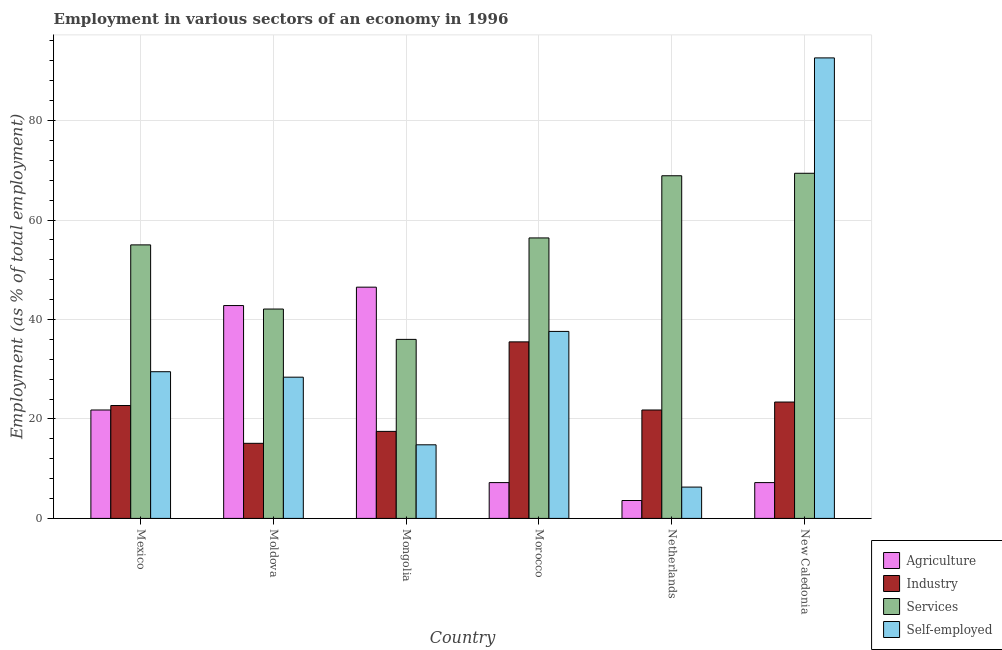How many groups of bars are there?
Ensure brevity in your answer.  6. What is the label of the 2nd group of bars from the left?
Give a very brief answer. Moldova. What is the percentage of self employed workers in Netherlands?
Offer a terse response. 6.3. Across all countries, what is the maximum percentage of self employed workers?
Ensure brevity in your answer.  92.6. Across all countries, what is the minimum percentage of workers in agriculture?
Give a very brief answer. 3.6. In which country was the percentage of workers in industry maximum?
Make the answer very short. Morocco. What is the total percentage of workers in services in the graph?
Keep it short and to the point. 327.8. What is the difference between the percentage of workers in industry in Mexico and that in Morocco?
Your answer should be compact. -12.8. What is the difference between the percentage of workers in agriculture in Mexico and the percentage of workers in industry in Moldova?
Keep it short and to the point. 6.7. What is the average percentage of workers in agriculture per country?
Ensure brevity in your answer.  21.52. What is the difference between the percentage of workers in agriculture and percentage of workers in industry in Moldova?
Make the answer very short. 27.7. In how many countries, is the percentage of self employed workers greater than 56 %?
Your answer should be compact. 1. What is the ratio of the percentage of self employed workers in Moldova to that in Mongolia?
Ensure brevity in your answer.  1.92. Is the percentage of workers in agriculture in Moldova less than that in Mongolia?
Your answer should be very brief. Yes. Is the difference between the percentage of workers in industry in Mexico and Moldova greater than the difference between the percentage of self employed workers in Mexico and Moldova?
Offer a terse response. Yes. What is the difference between the highest and the second highest percentage of workers in services?
Your answer should be compact. 0.5. What is the difference between the highest and the lowest percentage of self employed workers?
Offer a very short reply. 86.3. What does the 3rd bar from the left in Morocco represents?
Your answer should be very brief. Services. What does the 4th bar from the right in Moldova represents?
Keep it short and to the point. Agriculture. How many bars are there?
Offer a very short reply. 24. Are all the bars in the graph horizontal?
Offer a terse response. No. How many countries are there in the graph?
Offer a very short reply. 6. Are the values on the major ticks of Y-axis written in scientific E-notation?
Provide a short and direct response. No. Does the graph contain any zero values?
Provide a short and direct response. No. Where does the legend appear in the graph?
Keep it short and to the point. Bottom right. How are the legend labels stacked?
Your answer should be compact. Vertical. What is the title of the graph?
Your answer should be very brief. Employment in various sectors of an economy in 1996. What is the label or title of the X-axis?
Your answer should be very brief. Country. What is the label or title of the Y-axis?
Provide a short and direct response. Employment (as % of total employment). What is the Employment (as % of total employment) in Agriculture in Mexico?
Offer a very short reply. 21.8. What is the Employment (as % of total employment) of Industry in Mexico?
Keep it short and to the point. 22.7. What is the Employment (as % of total employment) of Services in Mexico?
Provide a succinct answer. 55. What is the Employment (as % of total employment) in Self-employed in Mexico?
Your answer should be very brief. 29.5. What is the Employment (as % of total employment) in Agriculture in Moldova?
Your answer should be compact. 42.8. What is the Employment (as % of total employment) in Industry in Moldova?
Your answer should be compact. 15.1. What is the Employment (as % of total employment) in Services in Moldova?
Provide a short and direct response. 42.1. What is the Employment (as % of total employment) of Self-employed in Moldova?
Offer a very short reply. 28.4. What is the Employment (as % of total employment) of Agriculture in Mongolia?
Provide a short and direct response. 46.5. What is the Employment (as % of total employment) in Self-employed in Mongolia?
Ensure brevity in your answer.  14.8. What is the Employment (as % of total employment) of Agriculture in Morocco?
Provide a succinct answer. 7.2. What is the Employment (as % of total employment) in Industry in Morocco?
Your answer should be very brief. 35.5. What is the Employment (as % of total employment) in Services in Morocco?
Offer a very short reply. 56.4. What is the Employment (as % of total employment) in Self-employed in Morocco?
Give a very brief answer. 37.6. What is the Employment (as % of total employment) of Agriculture in Netherlands?
Provide a succinct answer. 3.6. What is the Employment (as % of total employment) in Industry in Netherlands?
Give a very brief answer. 21.8. What is the Employment (as % of total employment) in Services in Netherlands?
Keep it short and to the point. 68.9. What is the Employment (as % of total employment) in Self-employed in Netherlands?
Your response must be concise. 6.3. What is the Employment (as % of total employment) of Agriculture in New Caledonia?
Make the answer very short. 7.2. What is the Employment (as % of total employment) of Industry in New Caledonia?
Give a very brief answer. 23.4. What is the Employment (as % of total employment) in Services in New Caledonia?
Ensure brevity in your answer.  69.4. What is the Employment (as % of total employment) of Self-employed in New Caledonia?
Ensure brevity in your answer.  92.6. Across all countries, what is the maximum Employment (as % of total employment) in Agriculture?
Your response must be concise. 46.5. Across all countries, what is the maximum Employment (as % of total employment) of Industry?
Give a very brief answer. 35.5. Across all countries, what is the maximum Employment (as % of total employment) of Services?
Provide a short and direct response. 69.4. Across all countries, what is the maximum Employment (as % of total employment) in Self-employed?
Offer a terse response. 92.6. Across all countries, what is the minimum Employment (as % of total employment) in Agriculture?
Give a very brief answer. 3.6. Across all countries, what is the minimum Employment (as % of total employment) of Industry?
Your answer should be compact. 15.1. Across all countries, what is the minimum Employment (as % of total employment) in Self-employed?
Provide a succinct answer. 6.3. What is the total Employment (as % of total employment) in Agriculture in the graph?
Provide a short and direct response. 129.1. What is the total Employment (as % of total employment) in Industry in the graph?
Your answer should be very brief. 136. What is the total Employment (as % of total employment) of Services in the graph?
Make the answer very short. 327.8. What is the total Employment (as % of total employment) of Self-employed in the graph?
Ensure brevity in your answer.  209.2. What is the difference between the Employment (as % of total employment) in Agriculture in Mexico and that in Moldova?
Provide a short and direct response. -21. What is the difference between the Employment (as % of total employment) of Industry in Mexico and that in Moldova?
Keep it short and to the point. 7.6. What is the difference between the Employment (as % of total employment) of Agriculture in Mexico and that in Mongolia?
Provide a short and direct response. -24.7. What is the difference between the Employment (as % of total employment) of Self-employed in Mexico and that in Mongolia?
Offer a very short reply. 14.7. What is the difference between the Employment (as % of total employment) in Industry in Mexico and that in Morocco?
Provide a short and direct response. -12.8. What is the difference between the Employment (as % of total employment) of Services in Mexico and that in Morocco?
Your response must be concise. -1.4. What is the difference between the Employment (as % of total employment) of Agriculture in Mexico and that in Netherlands?
Offer a terse response. 18.2. What is the difference between the Employment (as % of total employment) in Self-employed in Mexico and that in Netherlands?
Keep it short and to the point. 23.2. What is the difference between the Employment (as % of total employment) in Industry in Mexico and that in New Caledonia?
Provide a succinct answer. -0.7. What is the difference between the Employment (as % of total employment) of Services in Mexico and that in New Caledonia?
Offer a terse response. -14.4. What is the difference between the Employment (as % of total employment) in Self-employed in Mexico and that in New Caledonia?
Provide a succinct answer. -63.1. What is the difference between the Employment (as % of total employment) in Agriculture in Moldova and that in Mongolia?
Give a very brief answer. -3.7. What is the difference between the Employment (as % of total employment) of Services in Moldova and that in Mongolia?
Offer a terse response. 6.1. What is the difference between the Employment (as % of total employment) of Agriculture in Moldova and that in Morocco?
Keep it short and to the point. 35.6. What is the difference between the Employment (as % of total employment) in Industry in Moldova and that in Morocco?
Provide a succinct answer. -20.4. What is the difference between the Employment (as % of total employment) of Services in Moldova and that in Morocco?
Offer a terse response. -14.3. What is the difference between the Employment (as % of total employment) of Agriculture in Moldova and that in Netherlands?
Provide a succinct answer. 39.2. What is the difference between the Employment (as % of total employment) in Services in Moldova and that in Netherlands?
Give a very brief answer. -26.8. What is the difference between the Employment (as % of total employment) in Self-employed in Moldova and that in Netherlands?
Keep it short and to the point. 22.1. What is the difference between the Employment (as % of total employment) in Agriculture in Moldova and that in New Caledonia?
Make the answer very short. 35.6. What is the difference between the Employment (as % of total employment) in Industry in Moldova and that in New Caledonia?
Provide a succinct answer. -8.3. What is the difference between the Employment (as % of total employment) in Services in Moldova and that in New Caledonia?
Offer a terse response. -27.3. What is the difference between the Employment (as % of total employment) of Self-employed in Moldova and that in New Caledonia?
Keep it short and to the point. -64.2. What is the difference between the Employment (as % of total employment) in Agriculture in Mongolia and that in Morocco?
Make the answer very short. 39.3. What is the difference between the Employment (as % of total employment) of Industry in Mongolia and that in Morocco?
Provide a short and direct response. -18. What is the difference between the Employment (as % of total employment) of Services in Mongolia and that in Morocco?
Provide a succinct answer. -20.4. What is the difference between the Employment (as % of total employment) of Self-employed in Mongolia and that in Morocco?
Provide a succinct answer. -22.8. What is the difference between the Employment (as % of total employment) in Agriculture in Mongolia and that in Netherlands?
Ensure brevity in your answer.  42.9. What is the difference between the Employment (as % of total employment) in Industry in Mongolia and that in Netherlands?
Ensure brevity in your answer.  -4.3. What is the difference between the Employment (as % of total employment) in Services in Mongolia and that in Netherlands?
Offer a terse response. -32.9. What is the difference between the Employment (as % of total employment) in Self-employed in Mongolia and that in Netherlands?
Your answer should be compact. 8.5. What is the difference between the Employment (as % of total employment) in Agriculture in Mongolia and that in New Caledonia?
Your answer should be compact. 39.3. What is the difference between the Employment (as % of total employment) in Industry in Mongolia and that in New Caledonia?
Your answer should be compact. -5.9. What is the difference between the Employment (as % of total employment) of Services in Mongolia and that in New Caledonia?
Keep it short and to the point. -33.4. What is the difference between the Employment (as % of total employment) in Self-employed in Mongolia and that in New Caledonia?
Ensure brevity in your answer.  -77.8. What is the difference between the Employment (as % of total employment) of Services in Morocco and that in Netherlands?
Ensure brevity in your answer.  -12.5. What is the difference between the Employment (as % of total employment) of Self-employed in Morocco and that in Netherlands?
Keep it short and to the point. 31.3. What is the difference between the Employment (as % of total employment) of Agriculture in Morocco and that in New Caledonia?
Your response must be concise. 0. What is the difference between the Employment (as % of total employment) in Services in Morocco and that in New Caledonia?
Your response must be concise. -13. What is the difference between the Employment (as % of total employment) of Self-employed in Morocco and that in New Caledonia?
Offer a very short reply. -55. What is the difference between the Employment (as % of total employment) in Services in Netherlands and that in New Caledonia?
Your answer should be compact. -0.5. What is the difference between the Employment (as % of total employment) in Self-employed in Netherlands and that in New Caledonia?
Your answer should be very brief. -86.3. What is the difference between the Employment (as % of total employment) in Agriculture in Mexico and the Employment (as % of total employment) in Industry in Moldova?
Offer a very short reply. 6.7. What is the difference between the Employment (as % of total employment) of Agriculture in Mexico and the Employment (as % of total employment) of Services in Moldova?
Ensure brevity in your answer.  -20.3. What is the difference between the Employment (as % of total employment) in Agriculture in Mexico and the Employment (as % of total employment) in Self-employed in Moldova?
Provide a short and direct response. -6.6. What is the difference between the Employment (as % of total employment) of Industry in Mexico and the Employment (as % of total employment) of Services in Moldova?
Give a very brief answer. -19.4. What is the difference between the Employment (as % of total employment) in Industry in Mexico and the Employment (as % of total employment) in Self-employed in Moldova?
Ensure brevity in your answer.  -5.7. What is the difference between the Employment (as % of total employment) of Services in Mexico and the Employment (as % of total employment) of Self-employed in Moldova?
Offer a terse response. 26.6. What is the difference between the Employment (as % of total employment) of Agriculture in Mexico and the Employment (as % of total employment) of Services in Mongolia?
Your answer should be compact. -14.2. What is the difference between the Employment (as % of total employment) in Services in Mexico and the Employment (as % of total employment) in Self-employed in Mongolia?
Provide a succinct answer. 40.2. What is the difference between the Employment (as % of total employment) in Agriculture in Mexico and the Employment (as % of total employment) in Industry in Morocco?
Your answer should be very brief. -13.7. What is the difference between the Employment (as % of total employment) in Agriculture in Mexico and the Employment (as % of total employment) in Services in Morocco?
Provide a succinct answer. -34.6. What is the difference between the Employment (as % of total employment) in Agriculture in Mexico and the Employment (as % of total employment) in Self-employed in Morocco?
Your answer should be very brief. -15.8. What is the difference between the Employment (as % of total employment) in Industry in Mexico and the Employment (as % of total employment) in Services in Morocco?
Give a very brief answer. -33.7. What is the difference between the Employment (as % of total employment) of Industry in Mexico and the Employment (as % of total employment) of Self-employed in Morocco?
Ensure brevity in your answer.  -14.9. What is the difference between the Employment (as % of total employment) of Agriculture in Mexico and the Employment (as % of total employment) of Industry in Netherlands?
Provide a short and direct response. 0. What is the difference between the Employment (as % of total employment) of Agriculture in Mexico and the Employment (as % of total employment) of Services in Netherlands?
Provide a short and direct response. -47.1. What is the difference between the Employment (as % of total employment) of Agriculture in Mexico and the Employment (as % of total employment) of Self-employed in Netherlands?
Your answer should be compact. 15.5. What is the difference between the Employment (as % of total employment) in Industry in Mexico and the Employment (as % of total employment) in Services in Netherlands?
Provide a short and direct response. -46.2. What is the difference between the Employment (as % of total employment) in Services in Mexico and the Employment (as % of total employment) in Self-employed in Netherlands?
Your answer should be very brief. 48.7. What is the difference between the Employment (as % of total employment) of Agriculture in Mexico and the Employment (as % of total employment) of Services in New Caledonia?
Make the answer very short. -47.6. What is the difference between the Employment (as % of total employment) in Agriculture in Mexico and the Employment (as % of total employment) in Self-employed in New Caledonia?
Your response must be concise. -70.8. What is the difference between the Employment (as % of total employment) of Industry in Mexico and the Employment (as % of total employment) of Services in New Caledonia?
Your response must be concise. -46.7. What is the difference between the Employment (as % of total employment) of Industry in Mexico and the Employment (as % of total employment) of Self-employed in New Caledonia?
Offer a terse response. -69.9. What is the difference between the Employment (as % of total employment) in Services in Mexico and the Employment (as % of total employment) in Self-employed in New Caledonia?
Ensure brevity in your answer.  -37.6. What is the difference between the Employment (as % of total employment) in Agriculture in Moldova and the Employment (as % of total employment) in Industry in Mongolia?
Offer a very short reply. 25.3. What is the difference between the Employment (as % of total employment) of Agriculture in Moldova and the Employment (as % of total employment) of Self-employed in Mongolia?
Make the answer very short. 28. What is the difference between the Employment (as % of total employment) of Industry in Moldova and the Employment (as % of total employment) of Services in Mongolia?
Provide a succinct answer. -20.9. What is the difference between the Employment (as % of total employment) of Industry in Moldova and the Employment (as % of total employment) of Self-employed in Mongolia?
Provide a short and direct response. 0.3. What is the difference between the Employment (as % of total employment) of Services in Moldova and the Employment (as % of total employment) of Self-employed in Mongolia?
Ensure brevity in your answer.  27.3. What is the difference between the Employment (as % of total employment) of Industry in Moldova and the Employment (as % of total employment) of Services in Morocco?
Ensure brevity in your answer.  -41.3. What is the difference between the Employment (as % of total employment) of Industry in Moldova and the Employment (as % of total employment) of Self-employed in Morocco?
Your answer should be compact. -22.5. What is the difference between the Employment (as % of total employment) of Services in Moldova and the Employment (as % of total employment) of Self-employed in Morocco?
Your answer should be very brief. 4.5. What is the difference between the Employment (as % of total employment) in Agriculture in Moldova and the Employment (as % of total employment) in Industry in Netherlands?
Provide a short and direct response. 21. What is the difference between the Employment (as % of total employment) of Agriculture in Moldova and the Employment (as % of total employment) of Services in Netherlands?
Offer a very short reply. -26.1. What is the difference between the Employment (as % of total employment) of Agriculture in Moldova and the Employment (as % of total employment) of Self-employed in Netherlands?
Your answer should be very brief. 36.5. What is the difference between the Employment (as % of total employment) of Industry in Moldova and the Employment (as % of total employment) of Services in Netherlands?
Ensure brevity in your answer.  -53.8. What is the difference between the Employment (as % of total employment) of Industry in Moldova and the Employment (as % of total employment) of Self-employed in Netherlands?
Your answer should be very brief. 8.8. What is the difference between the Employment (as % of total employment) of Services in Moldova and the Employment (as % of total employment) of Self-employed in Netherlands?
Offer a very short reply. 35.8. What is the difference between the Employment (as % of total employment) of Agriculture in Moldova and the Employment (as % of total employment) of Services in New Caledonia?
Keep it short and to the point. -26.6. What is the difference between the Employment (as % of total employment) in Agriculture in Moldova and the Employment (as % of total employment) in Self-employed in New Caledonia?
Provide a short and direct response. -49.8. What is the difference between the Employment (as % of total employment) of Industry in Moldova and the Employment (as % of total employment) of Services in New Caledonia?
Your answer should be compact. -54.3. What is the difference between the Employment (as % of total employment) of Industry in Moldova and the Employment (as % of total employment) of Self-employed in New Caledonia?
Ensure brevity in your answer.  -77.5. What is the difference between the Employment (as % of total employment) in Services in Moldova and the Employment (as % of total employment) in Self-employed in New Caledonia?
Offer a very short reply. -50.5. What is the difference between the Employment (as % of total employment) in Agriculture in Mongolia and the Employment (as % of total employment) in Industry in Morocco?
Keep it short and to the point. 11. What is the difference between the Employment (as % of total employment) of Agriculture in Mongolia and the Employment (as % of total employment) of Services in Morocco?
Provide a short and direct response. -9.9. What is the difference between the Employment (as % of total employment) of Industry in Mongolia and the Employment (as % of total employment) of Services in Morocco?
Give a very brief answer. -38.9. What is the difference between the Employment (as % of total employment) in Industry in Mongolia and the Employment (as % of total employment) in Self-employed in Morocco?
Your response must be concise. -20.1. What is the difference between the Employment (as % of total employment) in Services in Mongolia and the Employment (as % of total employment) in Self-employed in Morocco?
Your response must be concise. -1.6. What is the difference between the Employment (as % of total employment) of Agriculture in Mongolia and the Employment (as % of total employment) of Industry in Netherlands?
Your response must be concise. 24.7. What is the difference between the Employment (as % of total employment) in Agriculture in Mongolia and the Employment (as % of total employment) in Services in Netherlands?
Offer a terse response. -22.4. What is the difference between the Employment (as % of total employment) of Agriculture in Mongolia and the Employment (as % of total employment) of Self-employed in Netherlands?
Your answer should be very brief. 40.2. What is the difference between the Employment (as % of total employment) of Industry in Mongolia and the Employment (as % of total employment) of Services in Netherlands?
Provide a short and direct response. -51.4. What is the difference between the Employment (as % of total employment) of Services in Mongolia and the Employment (as % of total employment) of Self-employed in Netherlands?
Provide a short and direct response. 29.7. What is the difference between the Employment (as % of total employment) of Agriculture in Mongolia and the Employment (as % of total employment) of Industry in New Caledonia?
Offer a very short reply. 23.1. What is the difference between the Employment (as % of total employment) in Agriculture in Mongolia and the Employment (as % of total employment) in Services in New Caledonia?
Offer a very short reply. -22.9. What is the difference between the Employment (as % of total employment) of Agriculture in Mongolia and the Employment (as % of total employment) of Self-employed in New Caledonia?
Your answer should be very brief. -46.1. What is the difference between the Employment (as % of total employment) in Industry in Mongolia and the Employment (as % of total employment) in Services in New Caledonia?
Offer a terse response. -51.9. What is the difference between the Employment (as % of total employment) of Industry in Mongolia and the Employment (as % of total employment) of Self-employed in New Caledonia?
Offer a very short reply. -75.1. What is the difference between the Employment (as % of total employment) of Services in Mongolia and the Employment (as % of total employment) of Self-employed in New Caledonia?
Your response must be concise. -56.6. What is the difference between the Employment (as % of total employment) in Agriculture in Morocco and the Employment (as % of total employment) in Industry in Netherlands?
Provide a succinct answer. -14.6. What is the difference between the Employment (as % of total employment) in Agriculture in Morocco and the Employment (as % of total employment) in Services in Netherlands?
Provide a succinct answer. -61.7. What is the difference between the Employment (as % of total employment) of Industry in Morocco and the Employment (as % of total employment) of Services in Netherlands?
Keep it short and to the point. -33.4. What is the difference between the Employment (as % of total employment) in Industry in Morocco and the Employment (as % of total employment) in Self-employed in Netherlands?
Keep it short and to the point. 29.2. What is the difference between the Employment (as % of total employment) of Services in Morocco and the Employment (as % of total employment) of Self-employed in Netherlands?
Ensure brevity in your answer.  50.1. What is the difference between the Employment (as % of total employment) of Agriculture in Morocco and the Employment (as % of total employment) of Industry in New Caledonia?
Give a very brief answer. -16.2. What is the difference between the Employment (as % of total employment) in Agriculture in Morocco and the Employment (as % of total employment) in Services in New Caledonia?
Your response must be concise. -62.2. What is the difference between the Employment (as % of total employment) of Agriculture in Morocco and the Employment (as % of total employment) of Self-employed in New Caledonia?
Give a very brief answer. -85.4. What is the difference between the Employment (as % of total employment) of Industry in Morocco and the Employment (as % of total employment) of Services in New Caledonia?
Give a very brief answer. -33.9. What is the difference between the Employment (as % of total employment) in Industry in Morocco and the Employment (as % of total employment) in Self-employed in New Caledonia?
Provide a succinct answer. -57.1. What is the difference between the Employment (as % of total employment) of Services in Morocco and the Employment (as % of total employment) of Self-employed in New Caledonia?
Your answer should be compact. -36.2. What is the difference between the Employment (as % of total employment) of Agriculture in Netherlands and the Employment (as % of total employment) of Industry in New Caledonia?
Ensure brevity in your answer.  -19.8. What is the difference between the Employment (as % of total employment) in Agriculture in Netherlands and the Employment (as % of total employment) in Services in New Caledonia?
Give a very brief answer. -65.8. What is the difference between the Employment (as % of total employment) in Agriculture in Netherlands and the Employment (as % of total employment) in Self-employed in New Caledonia?
Make the answer very short. -89. What is the difference between the Employment (as % of total employment) in Industry in Netherlands and the Employment (as % of total employment) in Services in New Caledonia?
Give a very brief answer. -47.6. What is the difference between the Employment (as % of total employment) of Industry in Netherlands and the Employment (as % of total employment) of Self-employed in New Caledonia?
Provide a succinct answer. -70.8. What is the difference between the Employment (as % of total employment) in Services in Netherlands and the Employment (as % of total employment) in Self-employed in New Caledonia?
Ensure brevity in your answer.  -23.7. What is the average Employment (as % of total employment) in Agriculture per country?
Your answer should be compact. 21.52. What is the average Employment (as % of total employment) in Industry per country?
Your answer should be very brief. 22.67. What is the average Employment (as % of total employment) in Services per country?
Keep it short and to the point. 54.63. What is the average Employment (as % of total employment) in Self-employed per country?
Make the answer very short. 34.87. What is the difference between the Employment (as % of total employment) of Agriculture and Employment (as % of total employment) of Services in Mexico?
Your answer should be very brief. -33.2. What is the difference between the Employment (as % of total employment) of Agriculture and Employment (as % of total employment) of Self-employed in Mexico?
Ensure brevity in your answer.  -7.7. What is the difference between the Employment (as % of total employment) in Industry and Employment (as % of total employment) in Services in Mexico?
Offer a very short reply. -32.3. What is the difference between the Employment (as % of total employment) of Industry and Employment (as % of total employment) of Self-employed in Mexico?
Keep it short and to the point. -6.8. What is the difference between the Employment (as % of total employment) in Agriculture and Employment (as % of total employment) in Industry in Moldova?
Your response must be concise. 27.7. What is the difference between the Employment (as % of total employment) in Industry and Employment (as % of total employment) in Self-employed in Moldova?
Offer a very short reply. -13.3. What is the difference between the Employment (as % of total employment) of Agriculture and Employment (as % of total employment) of Industry in Mongolia?
Provide a succinct answer. 29. What is the difference between the Employment (as % of total employment) of Agriculture and Employment (as % of total employment) of Services in Mongolia?
Give a very brief answer. 10.5. What is the difference between the Employment (as % of total employment) of Agriculture and Employment (as % of total employment) of Self-employed in Mongolia?
Your response must be concise. 31.7. What is the difference between the Employment (as % of total employment) in Industry and Employment (as % of total employment) in Services in Mongolia?
Your answer should be very brief. -18.5. What is the difference between the Employment (as % of total employment) in Services and Employment (as % of total employment) in Self-employed in Mongolia?
Offer a very short reply. 21.2. What is the difference between the Employment (as % of total employment) in Agriculture and Employment (as % of total employment) in Industry in Morocco?
Offer a very short reply. -28.3. What is the difference between the Employment (as % of total employment) in Agriculture and Employment (as % of total employment) in Services in Morocco?
Keep it short and to the point. -49.2. What is the difference between the Employment (as % of total employment) in Agriculture and Employment (as % of total employment) in Self-employed in Morocco?
Your answer should be compact. -30.4. What is the difference between the Employment (as % of total employment) in Industry and Employment (as % of total employment) in Services in Morocco?
Ensure brevity in your answer.  -20.9. What is the difference between the Employment (as % of total employment) in Industry and Employment (as % of total employment) in Self-employed in Morocco?
Make the answer very short. -2.1. What is the difference between the Employment (as % of total employment) of Services and Employment (as % of total employment) of Self-employed in Morocco?
Offer a terse response. 18.8. What is the difference between the Employment (as % of total employment) of Agriculture and Employment (as % of total employment) of Industry in Netherlands?
Ensure brevity in your answer.  -18.2. What is the difference between the Employment (as % of total employment) in Agriculture and Employment (as % of total employment) in Services in Netherlands?
Make the answer very short. -65.3. What is the difference between the Employment (as % of total employment) in Industry and Employment (as % of total employment) in Services in Netherlands?
Your answer should be very brief. -47.1. What is the difference between the Employment (as % of total employment) of Industry and Employment (as % of total employment) of Self-employed in Netherlands?
Make the answer very short. 15.5. What is the difference between the Employment (as % of total employment) of Services and Employment (as % of total employment) of Self-employed in Netherlands?
Give a very brief answer. 62.6. What is the difference between the Employment (as % of total employment) in Agriculture and Employment (as % of total employment) in Industry in New Caledonia?
Your answer should be very brief. -16.2. What is the difference between the Employment (as % of total employment) of Agriculture and Employment (as % of total employment) of Services in New Caledonia?
Ensure brevity in your answer.  -62.2. What is the difference between the Employment (as % of total employment) of Agriculture and Employment (as % of total employment) of Self-employed in New Caledonia?
Your response must be concise. -85.4. What is the difference between the Employment (as % of total employment) of Industry and Employment (as % of total employment) of Services in New Caledonia?
Give a very brief answer. -46. What is the difference between the Employment (as % of total employment) in Industry and Employment (as % of total employment) in Self-employed in New Caledonia?
Make the answer very short. -69.2. What is the difference between the Employment (as % of total employment) of Services and Employment (as % of total employment) of Self-employed in New Caledonia?
Your answer should be compact. -23.2. What is the ratio of the Employment (as % of total employment) of Agriculture in Mexico to that in Moldova?
Provide a short and direct response. 0.51. What is the ratio of the Employment (as % of total employment) in Industry in Mexico to that in Moldova?
Ensure brevity in your answer.  1.5. What is the ratio of the Employment (as % of total employment) of Services in Mexico to that in Moldova?
Your answer should be very brief. 1.31. What is the ratio of the Employment (as % of total employment) of Self-employed in Mexico to that in Moldova?
Your answer should be very brief. 1.04. What is the ratio of the Employment (as % of total employment) in Agriculture in Mexico to that in Mongolia?
Offer a very short reply. 0.47. What is the ratio of the Employment (as % of total employment) of Industry in Mexico to that in Mongolia?
Give a very brief answer. 1.3. What is the ratio of the Employment (as % of total employment) of Services in Mexico to that in Mongolia?
Keep it short and to the point. 1.53. What is the ratio of the Employment (as % of total employment) in Self-employed in Mexico to that in Mongolia?
Your answer should be compact. 1.99. What is the ratio of the Employment (as % of total employment) in Agriculture in Mexico to that in Morocco?
Offer a terse response. 3.03. What is the ratio of the Employment (as % of total employment) in Industry in Mexico to that in Morocco?
Offer a very short reply. 0.64. What is the ratio of the Employment (as % of total employment) in Services in Mexico to that in Morocco?
Offer a terse response. 0.98. What is the ratio of the Employment (as % of total employment) in Self-employed in Mexico to that in Morocco?
Your response must be concise. 0.78. What is the ratio of the Employment (as % of total employment) of Agriculture in Mexico to that in Netherlands?
Your answer should be compact. 6.06. What is the ratio of the Employment (as % of total employment) in Industry in Mexico to that in Netherlands?
Your response must be concise. 1.04. What is the ratio of the Employment (as % of total employment) of Services in Mexico to that in Netherlands?
Give a very brief answer. 0.8. What is the ratio of the Employment (as % of total employment) of Self-employed in Mexico to that in Netherlands?
Ensure brevity in your answer.  4.68. What is the ratio of the Employment (as % of total employment) of Agriculture in Mexico to that in New Caledonia?
Give a very brief answer. 3.03. What is the ratio of the Employment (as % of total employment) in Industry in Mexico to that in New Caledonia?
Offer a very short reply. 0.97. What is the ratio of the Employment (as % of total employment) of Services in Mexico to that in New Caledonia?
Ensure brevity in your answer.  0.79. What is the ratio of the Employment (as % of total employment) of Self-employed in Mexico to that in New Caledonia?
Give a very brief answer. 0.32. What is the ratio of the Employment (as % of total employment) in Agriculture in Moldova to that in Mongolia?
Offer a very short reply. 0.92. What is the ratio of the Employment (as % of total employment) in Industry in Moldova to that in Mongolia?
Offer a terse response. 0.86. What is the ratio of the Employment (as % of total employment) of Services in Moldova to that in Mongolia?
Give a very brief answer. 1.17. What is the ratio of the Employment (as % of total employment) in Self-employed in Moldova to that in Mongolia?
Offer a very short reply. 1.92. What is the ratio of the Employment (as % of total employment) in Agriculture in Moldova to that in Morocco?
Offer a terse response. 5.94. What is the ratio of the Employment (as % of total employment) in Industry in Moldova to that in Morocco?
Offer a very short reply. 0.43. What is the ratio of the Employment (as % of total employment) of Services in Moldova to that in Morocco?
Your answer should be very brief. 0.75. What is the ratio of the Employment (as % of total employment) in Self-employed in Moldova to that in Morocco?
Ensure brevity in your answer.  0.76. What is the ratio of the Employment (as % of total employment) of Agriculture in Moldova to that in Netherlands?
Your answer should be very brief. 11.89. What is the ratio of the Employment (as % of total employment) in Industry in Moldova to that in Netherlands?
Keep it short and to the point. 0.69. What is the ratio of the Employment (as % of total employment) of Services in Moldova to that in Netherlands?
Ensure brevity in your answer.  0.61. What is the ratio of the Employment (as % of total employment) of Self-employed in Moldova to that in Netherlands?
Keep it short and to the point. 4.51. What is the ratio of the Employment (as % of total employment) in Agriculture in Moldova to that in New Caledonia?
Provide a short and direct response. 5.94. What is the ratio of the Employment (as % of total employment) in Industry in Moldova to that in New Caledonia?
Keep it short and to the point. 0.65. What is the ratio of the Employment (as % of total employment) of Services in Moldova to that in New Caledonia?
Provide a succinct answer. 0.61. What is the ratio of the Employment (as % of total employment) in Self-employed in Moldova to that in New Caledonia?
Keep it short and to the point. 0.31. What is the ratio of the Employment (as % of total employment) of Agriculture in Mongolia to that in Morocco?
Provide a short and direct response. 6.46. What is the ratio of the Employment (as % of total employment) of Industry in Mongolia to that in Morocco?
Provide a succinct answer. 0.49. What is the ratio of the Employment (as % of total employment) of Services in Mongolia to that in Morocco?
Ensure brevity in your answer.  0.64. What is the ratio of the Employment (as % of total employment) of Self-employed in Mongolia to that in Morocco?
Ensure brevity in your answer.  0.39. What is the ratio of the Employment (as % of total employment) in Agriculture in Mongolia to that in Netherlands?
Offer a terse response. 12.92. What is the ratio of the Employment (as % of total employment) in Industry in Mongolia to that in Netherlands?
Offer a very short reply. 0.8. What is the ratio of the Employment (as % of total employment) in Services in Mongolia to that in Netherlands?
Give a very brief answer. 0.52. What is the ratio of the Employment (as % of total employment) of Self-employed in Mongolia to that in Netherlands?
Your answer should be compact. 2.35. What is the ratio of the Employment (as % of total employment) in Agriculture in Mongolia to that in New Caledonia?
Keep it short and to the point. 6.46. What is the ratio of the Employment (as % of total employment) of Industry in Mongolia to that in New Caledonia?
Make the answer very short. 0.75. What is the ratio of the Employment (as % of total employment) of Services in Mongolia to that in New Caledonia?
Ensure brevity in your answer.  0.52. What is the ratio of the Employment (as % of total employment) in Self-employed in Mongolia to that in New Caledonia?
Keep it short and to the point. 0.16. What is the ratio of the Employment (as % of total employment) of Agriculture in Morocco to that in Netherlands?
Offer a terse response. 2. What is the ratio of the Employment (as % of total employment) of Industry in Morocco to that in Netherlands?
Offer a very short reply. 1.63. What is the ratio of the Employment (as % of total employment) of Services in Morocco to that in Netherlands?
Your response must be concise. 0.82. What is the ratio of the Employment (as % of total employment) in Self-employed in Morocco to that in Netherlands?
Offer a terse response. 5.97. What is the ratio of the Employment (as % of total employment) of Agriculture in Morocco to that in New Caledonia?
Your answer should be compact. 1. What is the ratio of the Employment (as % of total employment) of Industry in Morocco to that in New Caledonia?
Provide a short and direct response. 1.52. What is the ratio of the Employment (as % of total employment) of Services in Morocco to that in New Caledonia?
Give a very brief answer. 0.81. What is the ratio of the Employment (as % of total employment) of Self-employed in Morocco to that in New Caledonia?
Offer a terse response. 0.41. What is the ratio of the Employment (as % of total employment) of Industry in Netherlands to that in New Caledonia?
Your response must be concise. 0.93. What is the ratio of the Employment (as % of total employment) in Services in Netherlands to that in New Caledonia?
Give a very brief answer. 0.99. What is the ratio of the Employment (as % of total employment) of Self-employed in Netherlands to that in New Caledonia?
Keep it short and to the point. 0.07. What is the difference between the highest and the second highest Employment (as % of total employment) of Services?
Make the answer very short. 0.5. What is the difference between the highest and the lowest Employment (as % of total employment) in Agriculture?
Give a very brief answer. 42.9. What is the difference between the highest and the lowest Employment (as % of total employment) in Industry?
Keep it short and to the point. 20.4. What is the difference between the highest and the lowest Employment (as % of total employment) of Services?
Your response must be concise. 33.4. What is the difference between the highest and the lowest Employment (as % of total employment) of Self-employed?
Keep it short and to the point. 86.3. 